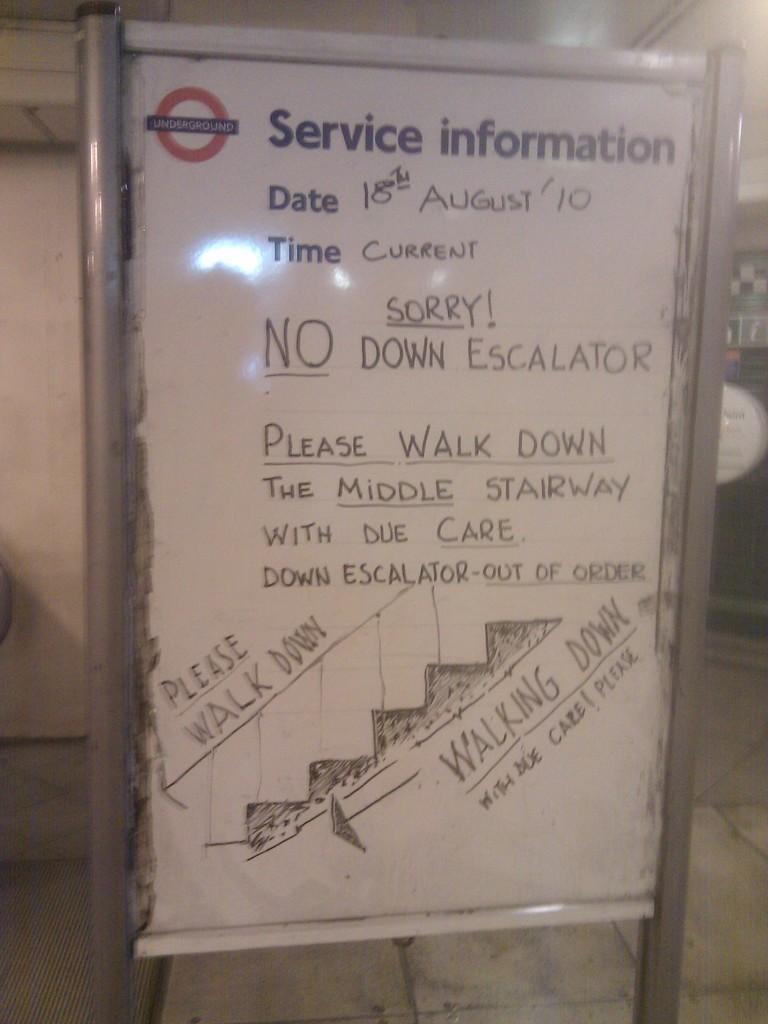Is the escalator not working here?
Keep it short and to the point. No. 